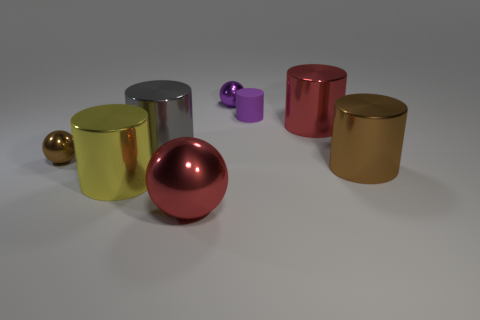Subtract all tiny balls. How many balls are left? 1 Subtract all purple cylinders. How many cylinders are left? 4 Subtract 3 cylinders. How many cylinders are left? 2 Add 1 red shiny things. How many objects exist? 9 Subtract all blue cylinders. Subtract all blue spheres. How many cylinders are left? 5 Subtract all balls. How many objects are left? 5 Add 7 big red metallic things. How many big red metallic things are left? 9 Add 5 large yellow metal things. How many large yellow metal things exist? 6 Subtract 0 gray balls. How many objects are left? 8 Subtract all brown shiny cylinders. Subtract all gray cylinders. How many objects are left? 6 